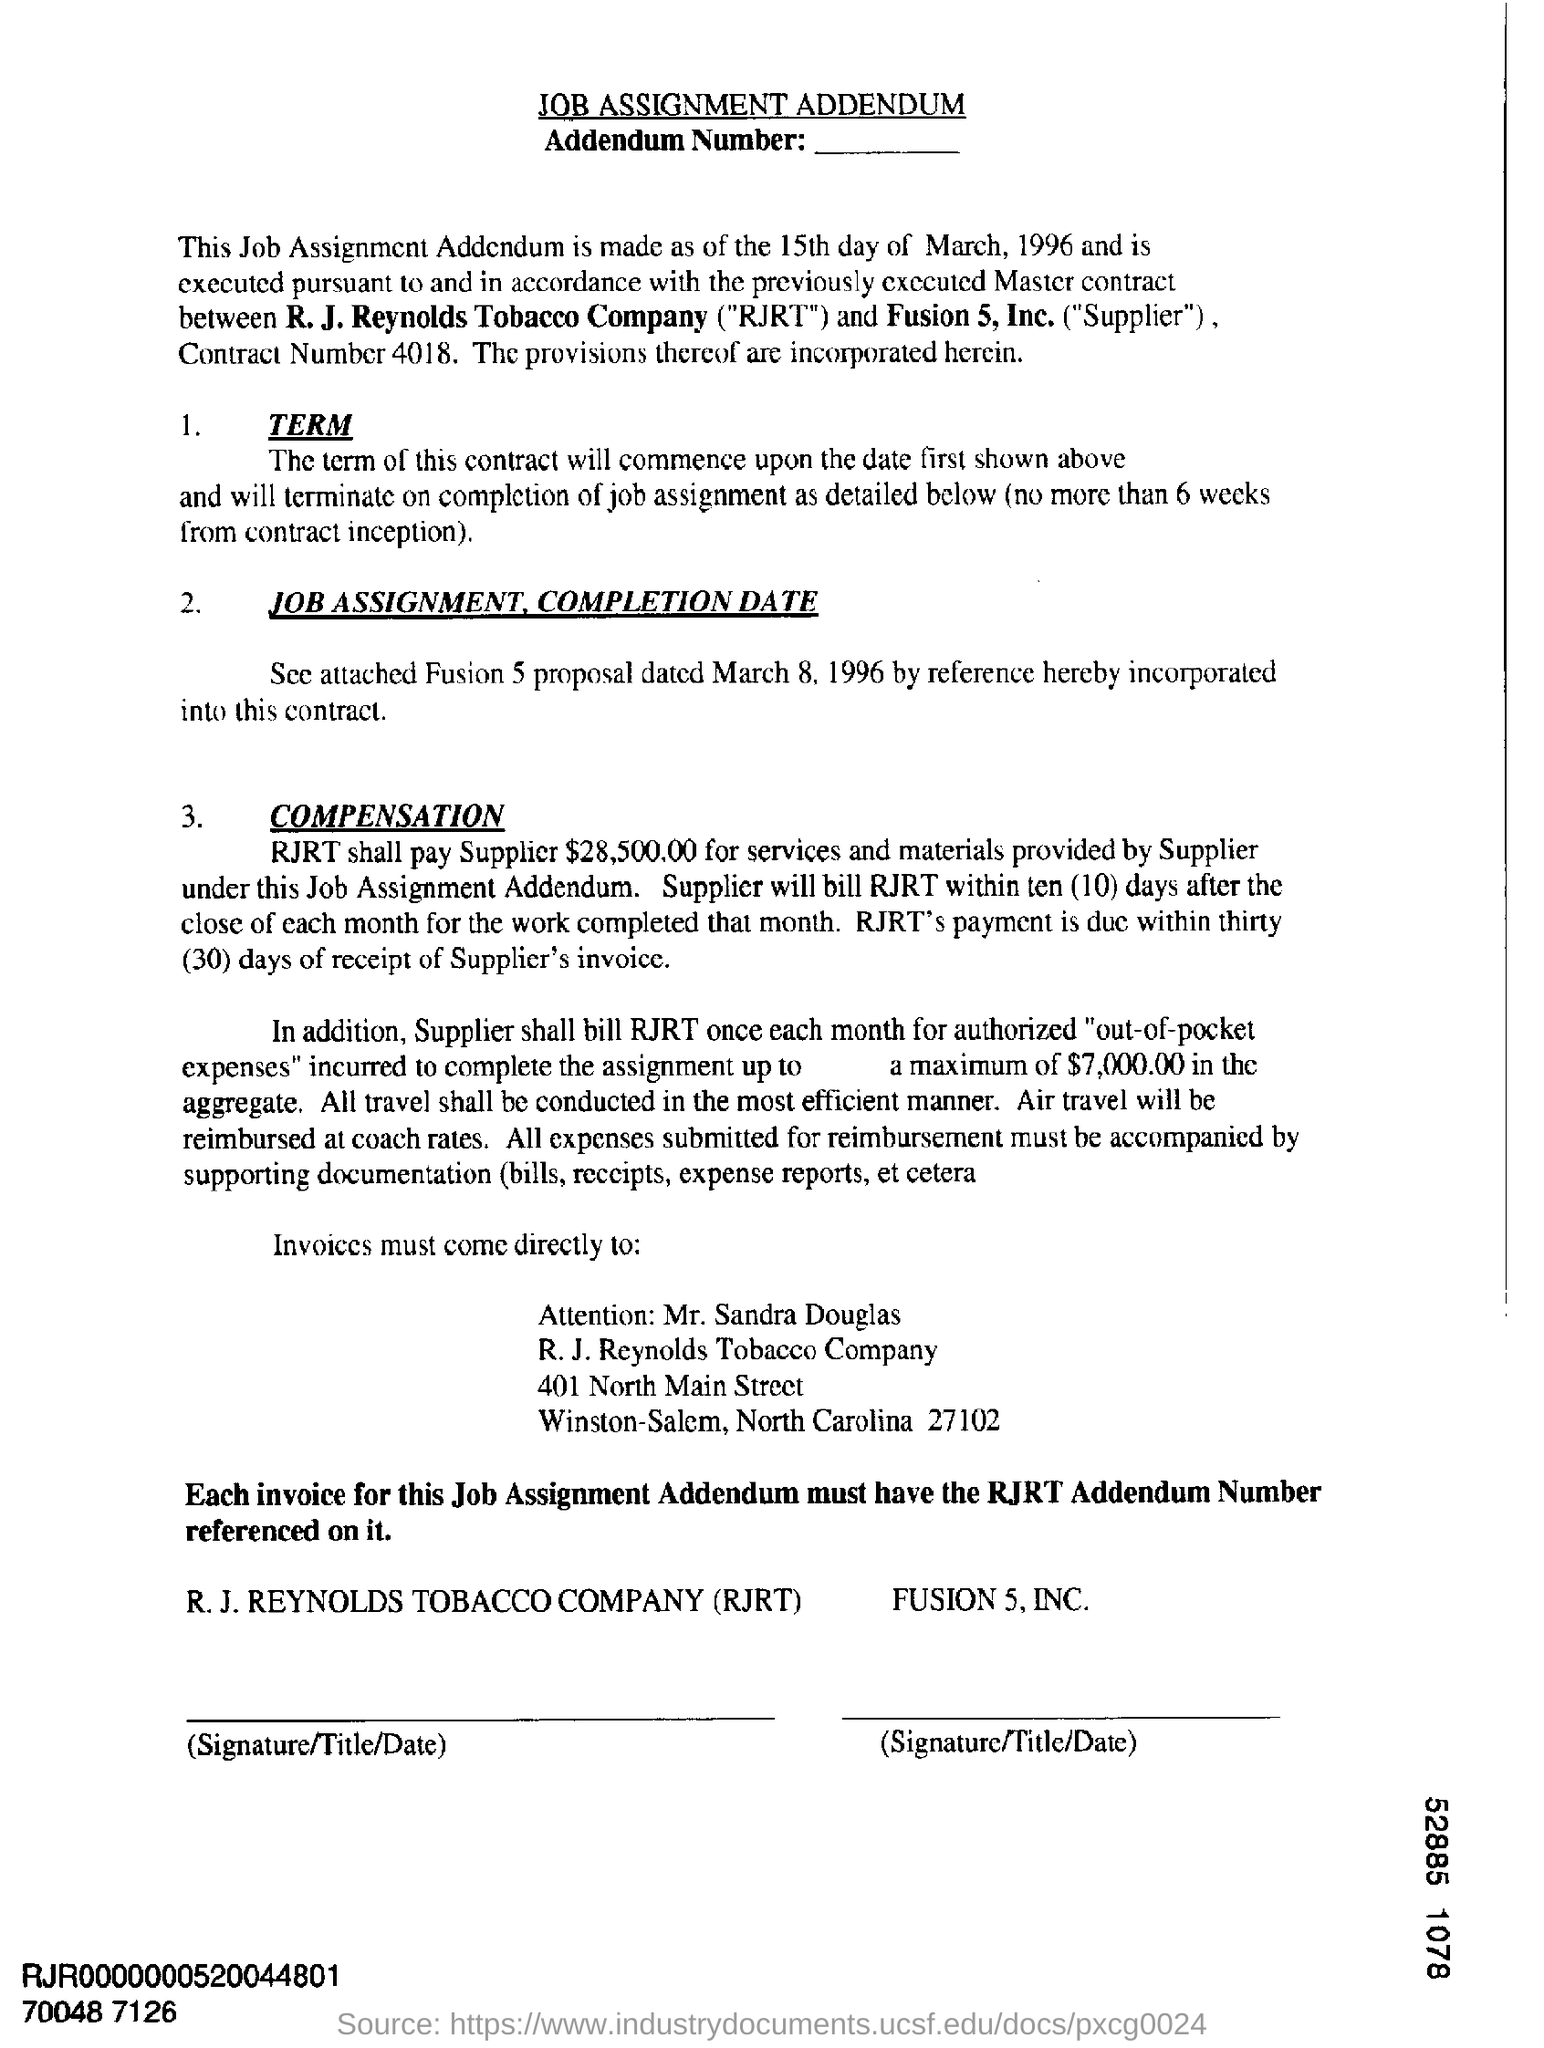What is the Contract Number mentioned in the document?
Give a very brief answer. 4018. 